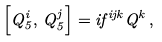<formula> <loc_0><loc_0><loc_500><loc_500>\left [ Q _ { 5 } ^ { i } , \, Q _ { 5 } ^ { j } \right ] = i f ^ { i j k } Q ^ { k } \, ,</formula> 